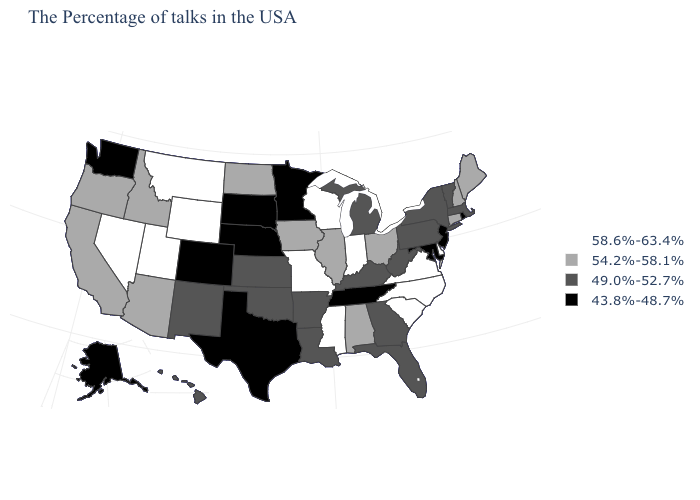What is the value of South Dakota?
Answer briefly. 43.8%-48.7%. Among the states that border Massachusetts , which have the highest value?
Write a very short answer. New Hampshire, Connecticut. Does the map have missing data?
Quick response, please. No. What is the value of Minnesota?
Be succinct. 43.8%-48.7%. Which states have the lowest value in the USA?
Keep it brief. Rhode Island, New Jersey, Maryland, Tennessee, Minnesota, Nebraska, Texas, South Dakota, Colorado, Washington, Alaska. What is the value of Arkansas?
Write a very short answer. 49.0%-52.7%. Name the states that have a value in the range 58.6%-63.4%?
Answer briefly. Delaware, Virginia, North Carolina, South Carolina, Indiana, Wisconsin, Mississippi, Missouri, Wyoming, Utah, Montana, Nevada. Does South Dakota have a lower value than Nebraska?
Answer briefly. No. What is the value of Colorado?
Keep it brief. 43.8%-48.7%. Among the states that border Utah , which have the lowest value?
Concise answer only. Colorado. How many symbols are there in the legend?
Keep it brief. 4. Name the states that have a value in the range 49.0%-52.7%?
Short answer required. Massachusetts, Vermont, New York, Pennsylvania, West Virginia, Florida, Georgia, Michigan, Kentucky, Louisiana, Arkansas, Kansas, Oklahoma, New Mexico, Hawaii. How many symbols are there in the legend?
Short answer required. 4. Among the states that border Maryland , which have the highest value?
Short answer required. Delaware, Virginia. Does Montana have the lowest value in the West?
Write a very short answer. No. 